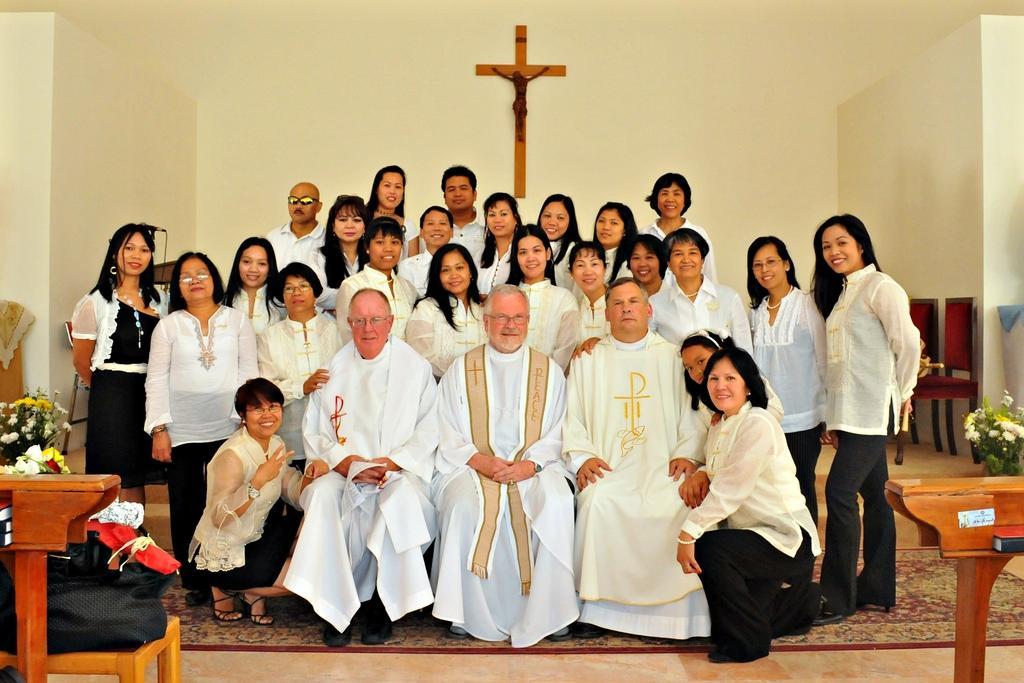Please provide a concise description of this image. In this image we can see a group of people, among them some are sitting and some are standing, we can see some flower pots, chairs, bags, tables and other objects, in the background we can see the wall with sculpture. 